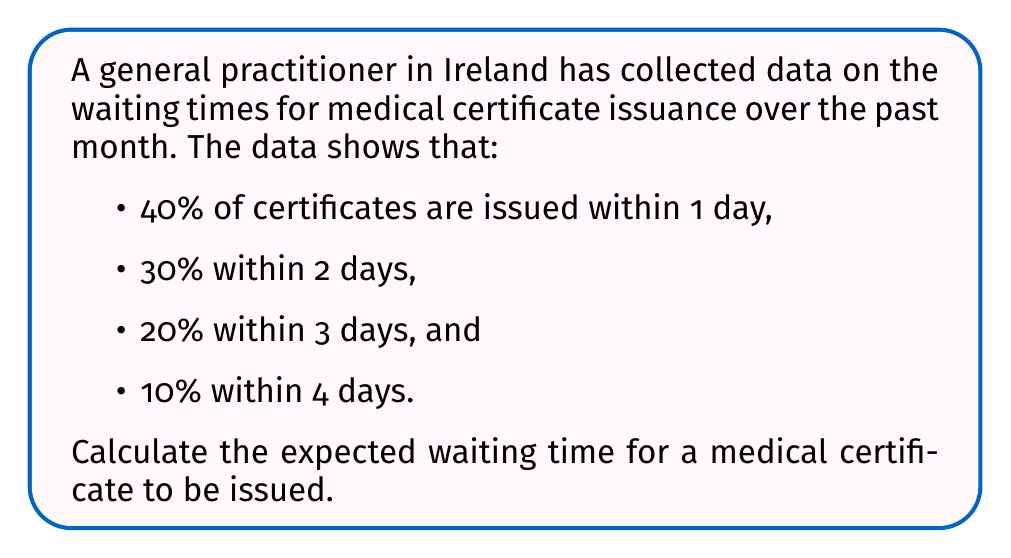What is the answer to this math problem? To calculate the expected waiting time, we need to use the concept of expected value. The expected value is the sum of each possible outcome multiplied by its probability.

Let's define our random variable X as the waiting time in days.

Step 1: Identify the probability distribution
P(X = 1) = 0.40
P(X = 2) = 0.30
P(X = 3) = 0.20
P(X = 4) = 0.10

Step 2: Calculate the expected value using the formula:
$$ E(X) = \sum_{i=1}^{n} x_i \cdot P(X = x_i) $$

Where $x_i$ are the possible values of X, and $P(X = x_i)$ is the probability of each value.

Step 3: Substitute the values into the formula
$$ E(X) = 1 \cdot 0.40 + 2 \cdot 0.30 + 3 \cdot 0.20 + 4 \cdot 0.10 $$

Step 4: Perform the calculations
$$ E(X) = 0.40 + 0.60 + 0.60 + 0.40 = 2 $$

Therefore, the expected waiting time for a medical certificate to be issued is 2 days.
Answer: 2 days 